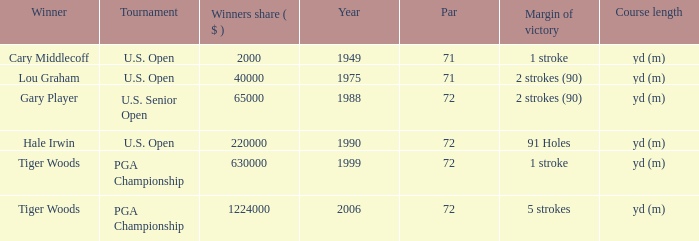When 1999 is the year how many tournaments are there? 1.0. 